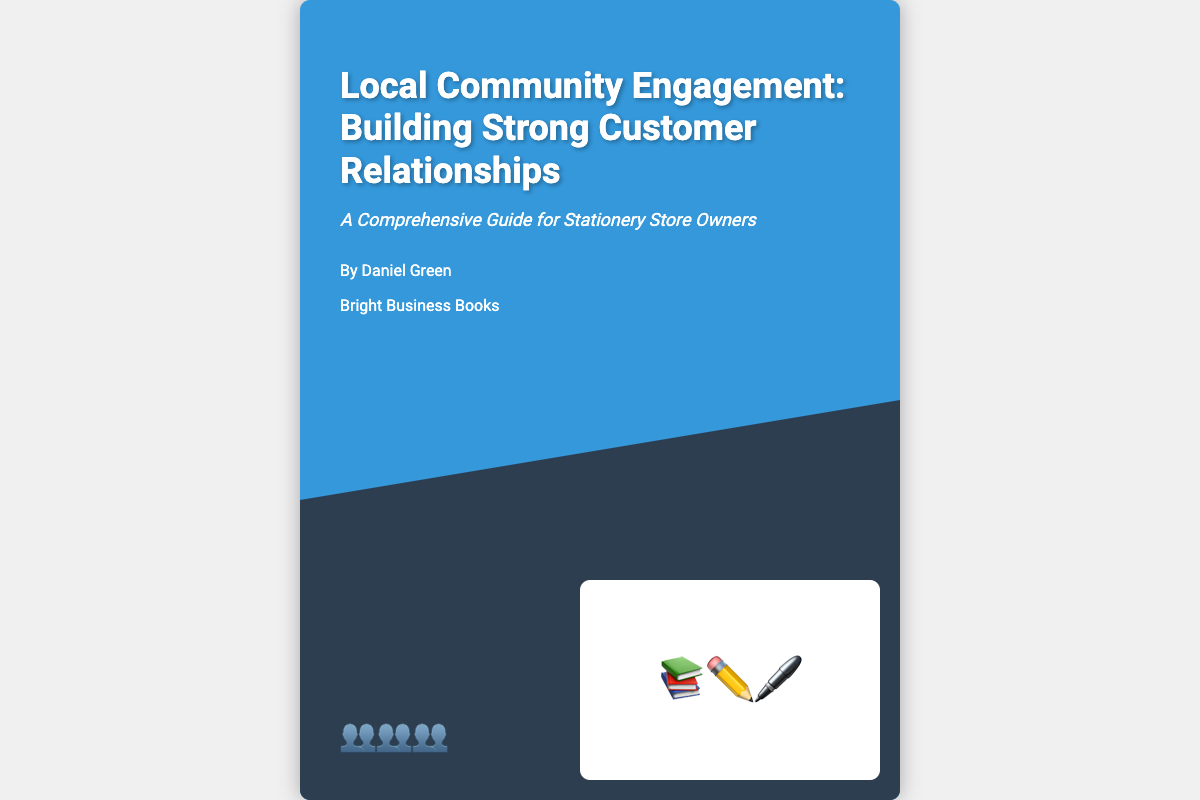What is the title of the book? The title of the book is prominently displayed in large font at the top of the cover.
Answer: Local Community Engagement: Building Strong Customer Relationships Who is the author of the book? The author's name is listed below the title, indicating who wrote the book.
Answer: Daniel Green What is the tagline of the book? The tagline is a brief descriptive phrase found right under the title, summarizing the book's focus.
Answer: A Comprehensive Guide for Stationery Store Owners What is the publisher's name? The publisher's name is noted towards the bottom of the cover, indicating which company published the book.
Answer: Bright Business Books What illustration is included at the bottom of the cover? The illustration features icons relevant to the book's theme and purpose, displayed at the bottom of the cover.
Answer: 📚✏️🖊️ How many people icons are shown on the cover? The number of people icons can be counted in the designated area at the bottom left of the cover.
Answer: 3 What color is the book cover? The background color of the cover is mentioned in the visual description of the document.
Answer: #3498db What is included on the cover relating to community engagement? The presence of people icons signifies community involvement, which relates to the book's theme.
Answer: People icons What type of book is this classified as? The content indicates it serves as a guide for a specific audience.
Answer: Guide 